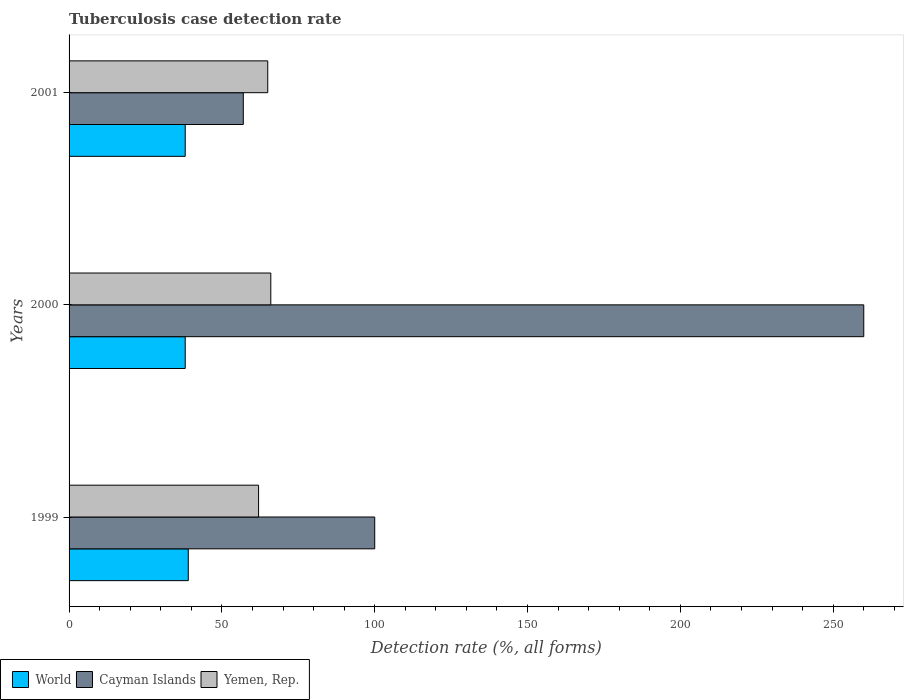How many groups of bars are there?
Provide a short and direct response. 3. Are the number of bars per tick equal to the number of legend labels?
Keep it short and to the point. Yes. How many bars are there on the 3rd tick from the bottom?
Provide a succinct answer. 3. What is the tuberculosis case detection rate in in Yemen, Rep. in 2001?
Your response must be concise. 65. Across all years, what is the maximum tuberculosis case detection rate in in Cayman Islands?
Provide a short and direct response. 260. In which year was the tuberculosis case detection rate in in Yemen, Rep. maximum?
Your answer should be very brief. 2000. In which year was the tuberculosis case detection rate in in World minimum?
Provide a short and direct response. 2000. What is the total tuberculosis case detection rate in in Cayman Islands in the graph?
Make the answer very short. 417. What is the difference between the tuberculosis case detection rate in in Yemen, Rep. in 1999 and that in 2001?
Offer a very short reply. -3. What is the difference between the tuberculosis case detection rate in in Cayman Islands in 2000 and the tuberculosis case detection rate in in Yemen, Rep. in 1999?
Provide a short and direct response. 198. What is the average tuberculosis case detection rate in in World per year?
Your answer should be very brief. 38.33. What is the ratio of the tuberculosis case detection rate in in Cayman Islands in 1999 to that in 2000?
Your answer should be very brief. 0.38. Is the tuberculosis case detection rate in in World in 1999 less than that in 2001?
Provide a short and direct response. No. What is the difference between the highest and the lowest tuberculosis case detection rate in in Yemen, Rep.?
Your answer should be very brief. 4. In how many years, is the tuberculosis case detection rate in in World greater than the average tuberculosis case detection rate in in World taken over all years?
Ensure brevity in your answer.  1. Is the sum of the tuberculosis case detection rate in in Cayman Islands in 2000 and 2001 greater than the maximum tuberculosis case detection rate in in Yemen, Rep. across all years?
Make the answer very short. Yes. What does the 3rd bar from the bottom in 2000 represents?
Offer a terse response. Yemen, Rep. Is it the case that in every year, the sum of the tuberculosis case detection rate in in Cayman Islands and tuberculosis case detection rate in in World is greater than the tuberculosis case detection rate in in Yemen, Rep.?
Provide a succinct answer. Yes. Are all the bars in the graph horizontal?
Offer a very short reply. Yes. How many years are there in the graph?
Provide a short and direct response. 3. What is the difference between two consecutive major ticks on the X-axis?
Ensure brevity in your answer.  50. Are the values on the major ticks of X-axis written in scientific E-notation?
Make the answer very short. No. Where does the legend appear in the graph?
Give a very brief answer. Bottom left. How many legend labels are there?
Your response must be concise. 3. How are the legend labels stacked?
Make the answer very short. Horizontal. What is the title of the graph?
Make the answer very short. Tuberculosis case detection rate. Does "Nicaragua" appear as one of the legend labels in the graph?
Your response must be concise. No. What is the label or title of the X-axis?
Make the answer very short. Detection rate (%, all forms). What is the Detection rate (%, all forms) of World in 1999?
Your answer should be very brief. 39. What is the Detection rate (%, all forms) in Yemen, Rep. in 1999?
Offer a terse response. 62. What is the Detection rate (%, all forms) in World in 2000?
Your response must be concise. 38. What is the Detection rate (%, all forms) in Cayman Islands in 2000?
Your answer should be very brief. 260. What is the Detection rate (%, all forms) of Yemen, Rep. in 2001?
Provide a succinct answer. 65. Across all years, what is the maximum Detection rate (%, all forms) of Cayman Islands?
Offer a very short reply. 260. Across all years, what is the maximum Detection rate (%, all forms) in Yemen, Rep.?
Give a very brief answer. 66. Across all years, what is the minimum Detection rate (%, all forms) in Cayman Islands?
Offer a very short reply. 57. What is the total Detection rate (%, all forms) of World in the graph?
Offer a terse response. 115. What is the total Detection rate (%, all forms) in Cayman Islands in the graph?
Ensure brevity in your answer.  417. What is the total Detection rate (%, all forms) in Yemen, Rep. in the graph?
Make the answer very short. 193. What is the difference between the Detection rate (%, all forms) of World in 1999 and that in 2000?
Your answer should be very brief. 1. What is the difference between the Detection rate (%, all forms) of Cayman Islands in 1999 and that in 2000?
Offer a terse response. -160. What is the difference between the Detection rate (%, all forms) in Yemen, Rep. in 1999 and that in 2000?
Keep it short and to the point. -4. What is the difference between the Detection rate (%, all forms) of World in 1999 and that in 2001?
Your response must be concise. 1. What is the difference between the Detection rate (%, all forms) in Cayman Islands in 1999 and that in 2001?
Provide a succinct answer. 43. What is the difference between the Detection rate (%, all forms) of World in 2000 and that in 2001?
Give a very brief answer. 0. What is the difference between the Detection rate (%, all forms) of Cayman Islands in 2000 and that in 2001?
Your response must be concise. 203. What is the difference between the Detection rate (%, all forms) of Yemen, Rep. in 2000 and that in 2001?
Make the answer very short. 1. What is the difference between the Detection rate (%, all forms) in World in 1999 and the Detection rate (%, all forms) in Cayman Islands in 2000?
Your answer should be compact. -221. What is the difference between the Detection rate (%, all forms) in World in 1999 and the Detection rate (%, all forms) in Yemen, Rep. in 2000?
Keep it short and to the point. -27. What is the difference between the Detection rate (%, all forms) of World in 1999 and the Detection rate (%, all forms) of Yemen, Rep. in 2001?
Provide a succinct answer. -26. What is the difference between the Detection rate (%, all forms) in Cayman Islands in 1999 and the Detection rate (%, all forms) in Yemen, Rep. in 2001?
Offer a very short reply. 35. What is the difference between the Detection rate (%, all forms) of Cayman Islands in 2000 and the Detection rate (%, all forms) of Yemen, Rep. in 2001?
Ensure brevity in your answer.  195. What is the average Detection rate (%, all forms) of World per year?
Offer a very short reply. 38.33. What is the average Detection rate (%, all forms) in Cayman Islands per year?
Keep it short and to the point. 139. What is the average Detection rate (%, all forms) of Yemen, Rep. per year?
Ensure brevity in your answer.  64.33. In the year 1999, what is the difference between the Detection rate (%, all forms) of World and Detection rate (%, all forms) of Cayman Islands?
Provide a short and direct response. -61. In the year 2000, what is the difference between the Detection rate (%, all forms) of World and Detection rate (%, all forms) of Cayman Islands?
Provide a short and direct response. -222. In the year 2000, what is the difference between the Detection rate (%, all forms) in Cayman Islands and Detection rate (%, all forms) in Yemen, Rep.?
Keep it short and to the point. 194. In the year 2001, what is the difference between the Detection rate (%, all forms) in World and Detection rate (%, all forms) in Yemen, Rep.?
Your answer should be compact. -27. What is the ratio of the Detection rate (%, all forms) of World in 1999 to that in 2000?
Your answer should be compact. 1.03. What is the ratio of the Detection rate (%, all forms) of Cayman Islands in 1999 to that in 2000?
Keep it short and to the point. 0.38. What is the ratio of the Detection rate (%, all forms) in Yemen, Rep. in 1999 to that in 2000?
Offer a very short reply. 0.94. What is the ratio of the Detection rate (%, all forms) in World in 1999 to that in 2001?
Make the answer very short. 1.03. What is the ratio of the Detection rate (%, all forms) of Cayman Islands in 1999 to that in 2001?
Provide a succinct answer. 1.75. What is the ratio of the Detection rate (%, all forms) of Yemen, Rep. in 1999 to that in 2001?
Offer a terse response. 0.95. What is the ratio of the Detection rate (%, all forms) of Cayman Islands in 2000 to that in 2001?
Offer a very short reply. 4.56. What is the ratio of the Detection rate (%, all forms) in Yemen, Rep. in 2000 to that in 2001?
Your response must be concise. 1.02. What is the difference between the highest and the second highest Detection rate (%, all forms) of Cayman Islands?
Give a very brief answer. 160. What is the difference between the highest and the second highest Detection rate (%, all forms) of Yemen, Rep.?
Provide a short and direct response. 1. What is the difference between the highest and the lowest Detection rate (%, all forms) of World?
Provide a short and direct response. 1. What is the difference between the highest and the lowest Detection rate (%, all forms) in Cayman Islands?
Your response must be concise. 203. What is the difference between the highest and the lowest Detection rate (%, all forms) in Yemen, Rep.?
Your response must be concise. 4. 